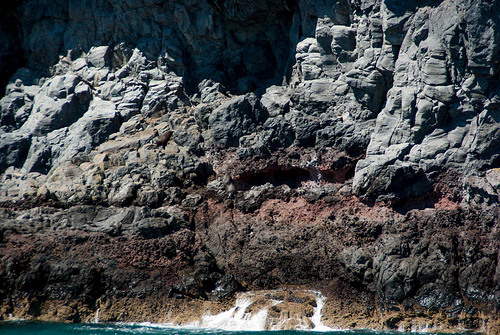<image>
Is there a rock in the water? No. The rock is not contained within the water. These objects have a different spatial relationship. 